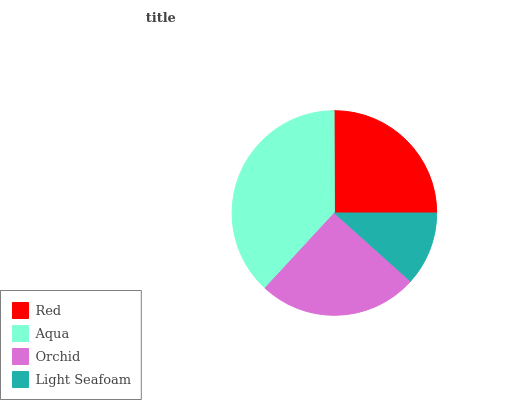Is Light Seafoam the minimum?
Answer yes or no. Yes. Is Aqua the maximum?
Answer yes or no. Yes. Is Orchid the minimum?
Answer yes or no. No. Is Orchid the maximum?
Answer yes or no. No. Is Aqua greater than Orchid?
Answer yes or no. Yes. Is Orchid less than Aqua?
Answer yes or no. Yes. Is Orchid greater than Aqua?
Answer yes or no. No. Is Aqua less than Orchid?
Answer yes or no. No. Is Orchid the high median?
Answer yes or no. Yes. Is Red the low median?
Answer yes or no. Yes. Is Red the high median?
Answer yes or no. No. Is Light Seafoam the low median?
Answer yes or no. No. 